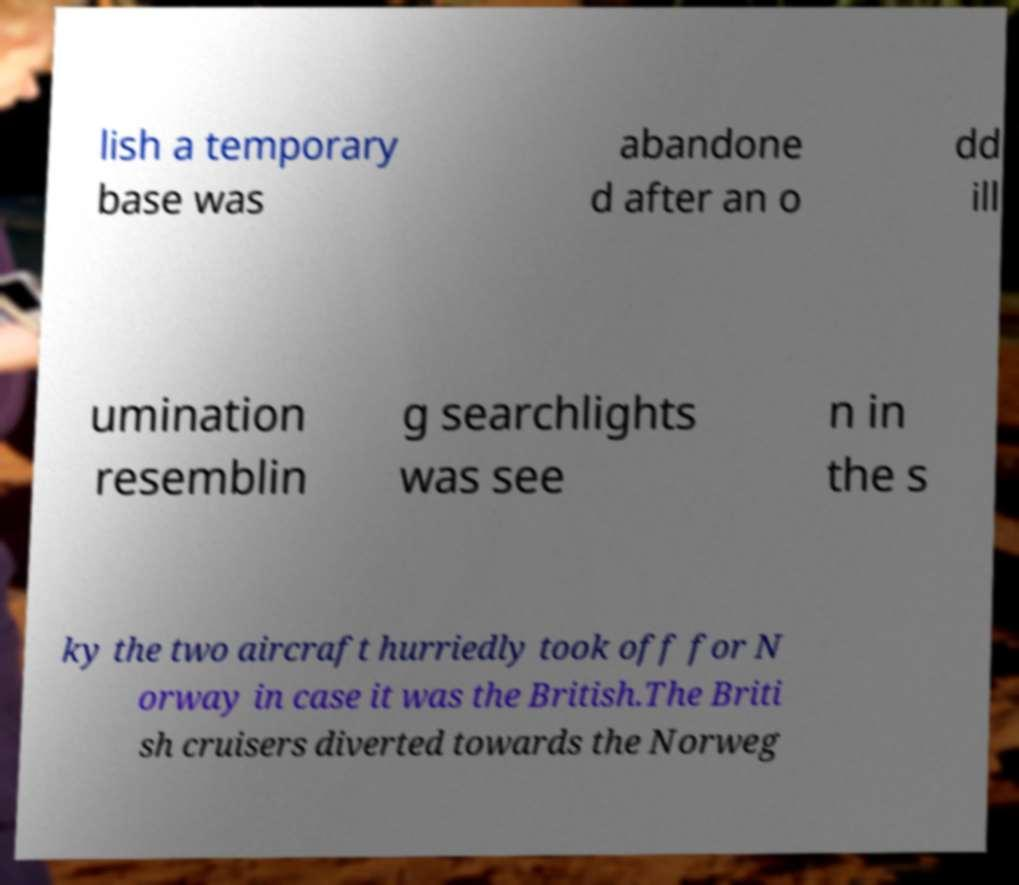Could you assist in decoding the text presented in this image and type it out clearly? lish a temporary base was abandone d after an o dd ill umination resemblin g searchlights was see n in the s ky the two aircraft hurriedly took off for N orway in case it was the British.The Briti sh cruisers diverted towards the Norweg 